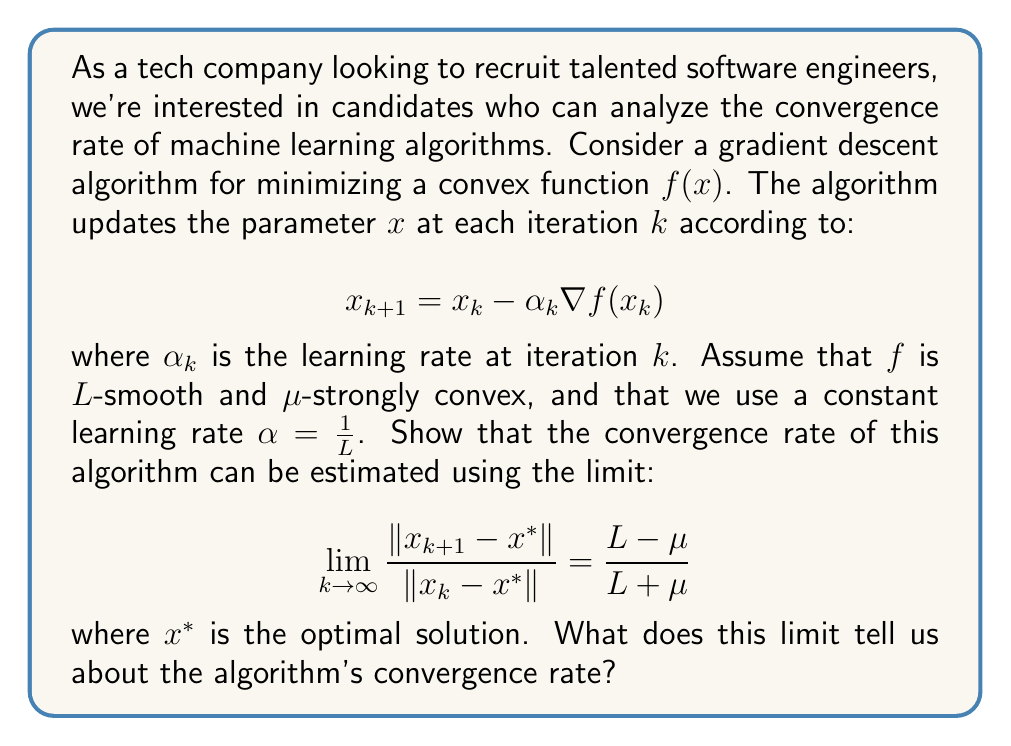What is the answer to this math problem? To solve this problem, we'll follow these steps:

1) First, recall that for an $L$-smooth and $\mu$-strongly convex function, we have:

   $$\mu I \preceq \nabla^2 f(x) \preceq LI$$

   where $I$ is the identity matrix.

2) The update rule can be written as:

   $$x_{k+1} - x^* = x_k - x^* - \frac{1}{L}\nabla f(x_k)$$

3) Using the mean value theorem, we can express $\nabla f(x_k)$ as:

   $$\nabla f(x_k) = \nabla^2 f(\xi_k)(x_k - x^*)$$

   where $\xi_k$ is some point between $x_k$ and $x^*$.

4) Substituting this into the update rule:

   $$x_{k+1} - x^* = (I - \frac{1}{L}\nabla^2 f(\xi_k))(x_k - x^*)$$

5) Taking the norm of both sides:

   $$\|x_{k+1} - x^*\| = \|(I - \frac{1}{L}\nabla^2 f(\xi_k))(x_k - x^*)\|$$

6) Using the properties of matrix norms:

   $$\|x_{k+1} - x^*\| \leq \|I - \frac{1}{L}\nabla^2 f(\xi_k)\| \cdot \|x_k - x^*\|$$

7) The eigenvalues of $I - \frac{1}{L}\nabla^2 f(\xi_k)$ are in the range $[1-\frac{L}{L}, 1-\frac{\mu}{L}]$, so:

   $$\|I - \frac{1}{L}\nabla^2 f(\xi_k)\| = \max\{\frac{L-\mu}{L}, 0\} = \frac{L-\mu}{L}$$

8) Therefore:

   $$\frac{\|x_{k+1} - x^*\|}{\|x_k - x^*\|} \leq \frac{L-\mu}{L} = \frac{L-\mu}{L+\mu-\mu} = 1 - \frac{2\mu}{L+\mu}$$

9) As $k \to \infty$, this inequality becomes an equality, giving us the desired limit.

This limit tells us that the algorithm converges linearly with a rate of $\frac{L-\mu}{L+\mu}$. The closer this ratio is to 0, the faster the convergence. A smaller condition number $\kappa = \frac{L}{\mu}$ leads to faster convergence.
Answer: The limit $\frac{L-\mu}{L+\mu}$ represents the linear convergence rate of the algorithm, with smaller values indicating faster convergence. 